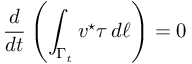Convert formula to latex. <formula><loc_0><loc_0><loc_500><loc_500>\frac { d } { d t } \left ( \int _ { \Gamma _ { t } } v ^ { ^ { * } } \tau \, d \ell \right ) = 0</formula> 